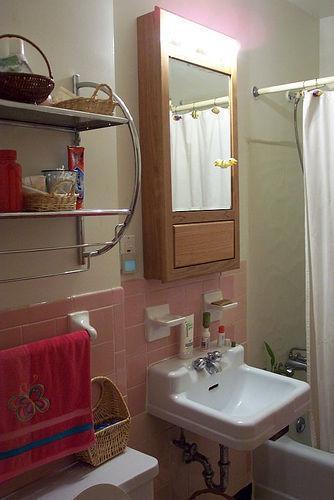How many horses are there?
Give a very brief answer. 0. 